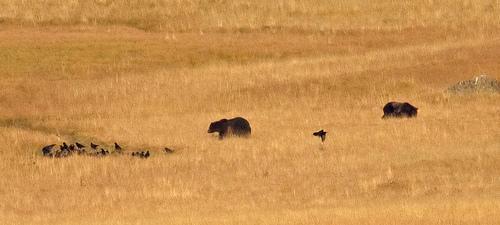How many bears are in the picture?
Give a very brief answer. 2. How many birds are flying?
Give a very brief answer. 1. 